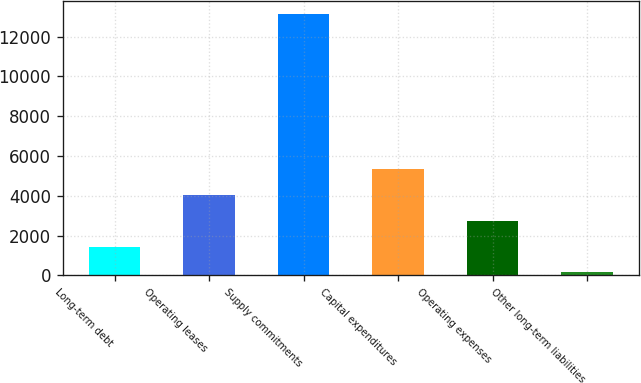Convert chart. <chart><loc_0><loc_0><loc_500><loc_500><bar_chart><fcel>Long-term debt<fcel>Operating leases<fcel>Supply commitments<fcel>Capital expenditures<fcel>Operating expenses<fcel>Other long-term liabilities<nl><fcel>1446.3<fcel>4048.9<fcel>13158<fcel>5350.2<fcel>2747.6<fcel>145<nl></chart> 